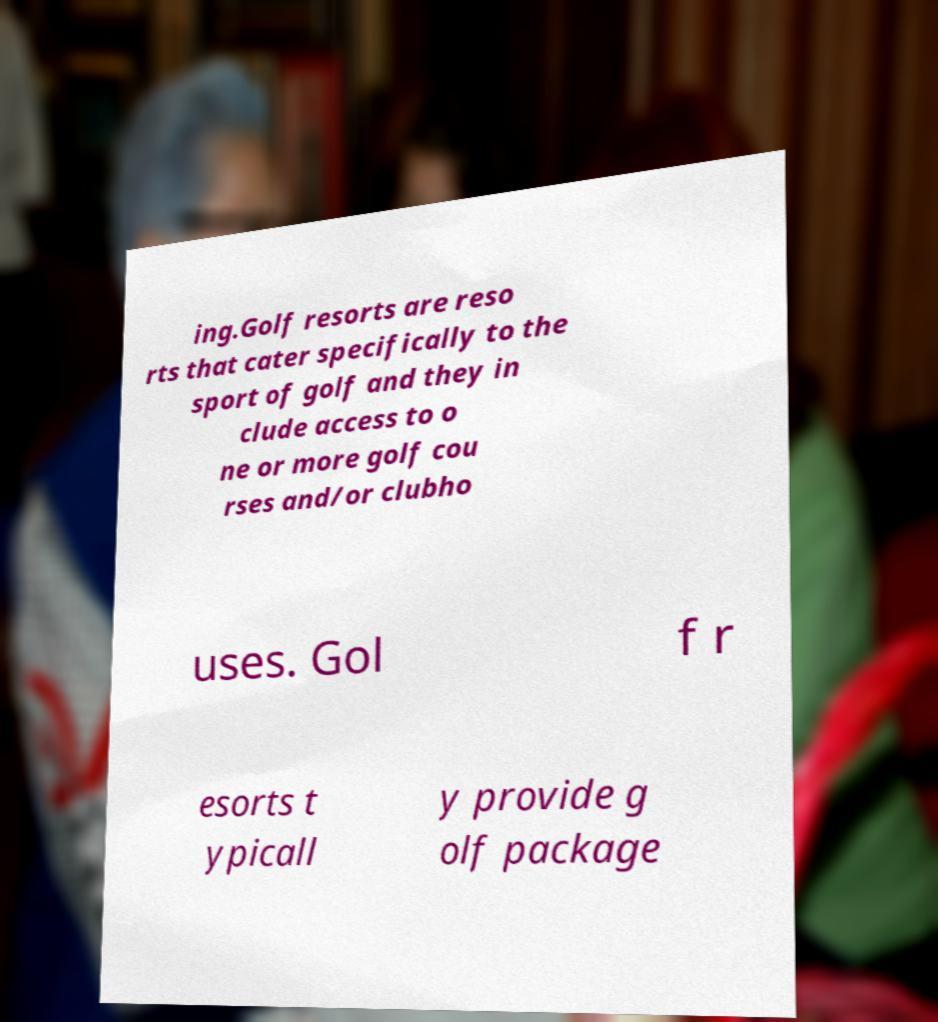Can you read and provide the text displayed in the image?This photo seems to have some interesting text. Can you extract and type it out for me? ing.Golf resorts are reso rts that cater specifically to the sport of golf and they in clude access to o ne or more golf cou rses and/or clubho uses. Gol f r esorts t ypicall y provide g olf package 